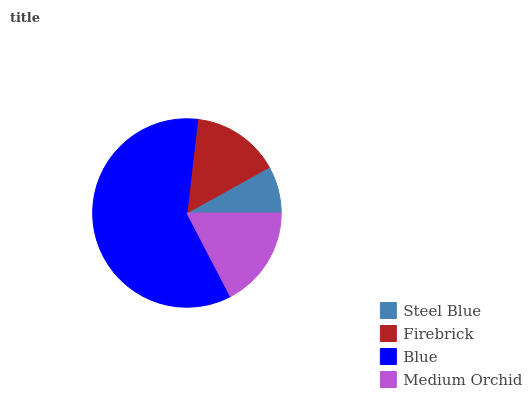Is Steel Blue the minimum?
Answer yes or no. Yes. Is Blue the maximum?
Answer yes or no. Yes. Is Firebrick the minimum?
Answer yes or no. No. Is Firebrick the maximum?
Answer yes or no. No. Is Firebrick greater than Steel Blue?
Answer yes or no. Yes. Is Steel Blue less than Firebrick?
Answer yes or no. Yes. Is Steel Blue greater than Firebrick?
Answer yes or no. No. Is Firebrick less than Steel Blue?
Answer yes or no. No. Is Medium Orchid the high median?
Answer yes or no. Yes. Is Firebrick the low median?
Answer yes or no. Yes. Is Firebrick the high median?
Answer yes or no. No. Is Blue the low median?
Answer yes or no. No. 